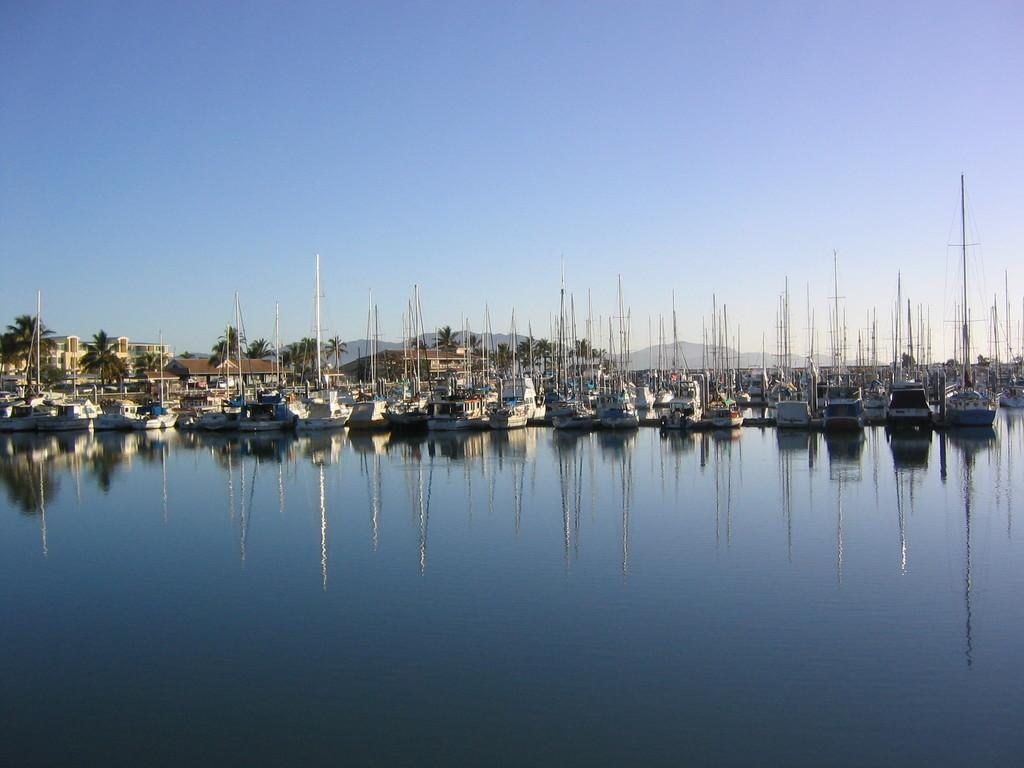What is in the water in the image? There are ships in the water in the image. What can be seen in the background of the image? There are buildings and trees in the background of the image. What colors are the buildings in the image? The buildings are in brown and cream colors. What color are the trees in the image? The trees are green. What color is the sky in the image? The sky is blue in the image. Can you read the letter that is floating on the water in the image? There is no letter present in the image; it only features ships in the water, buildings and trees in the background, and a blue sky. 